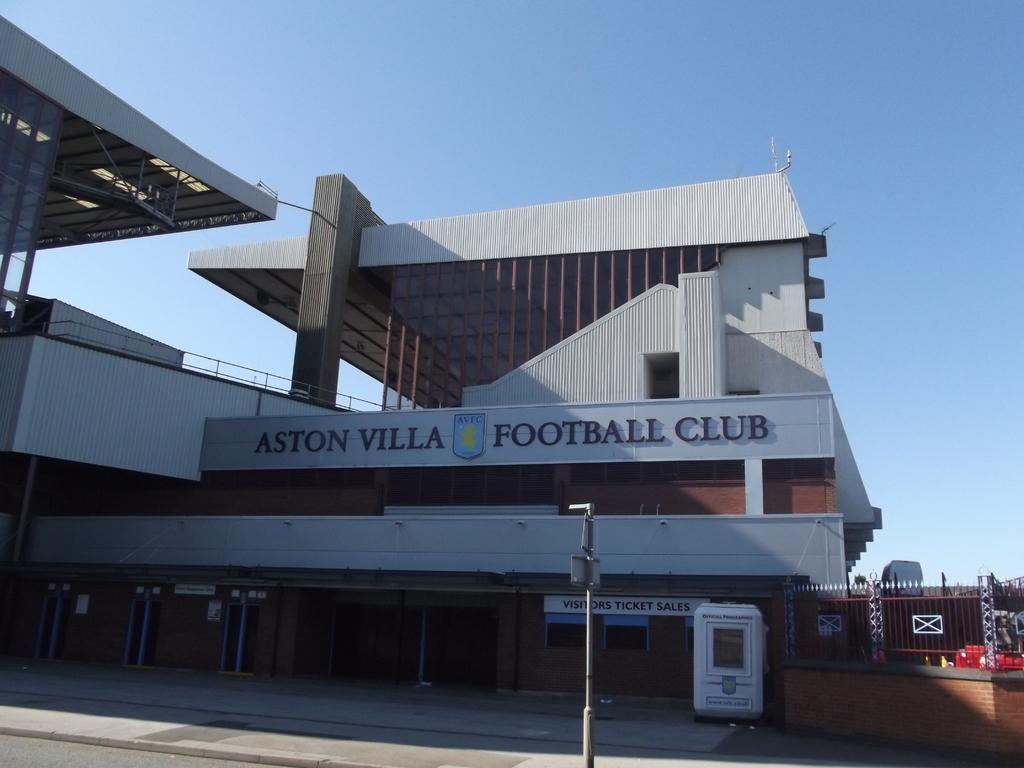Could you give a brief overview of what you see in this image? In the picture I can see buildings, fence, a pole and something written on the building. In the background I can see the sky. 